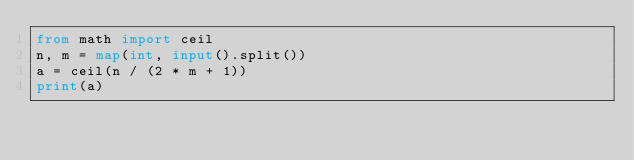<code> <loc_0><loc_0><loc_500><loc_500><_Python_>from math import ceil
n, m = map(int, input().split())
a = ceil(n / (2 * m + 1))
print(a)
</code> 